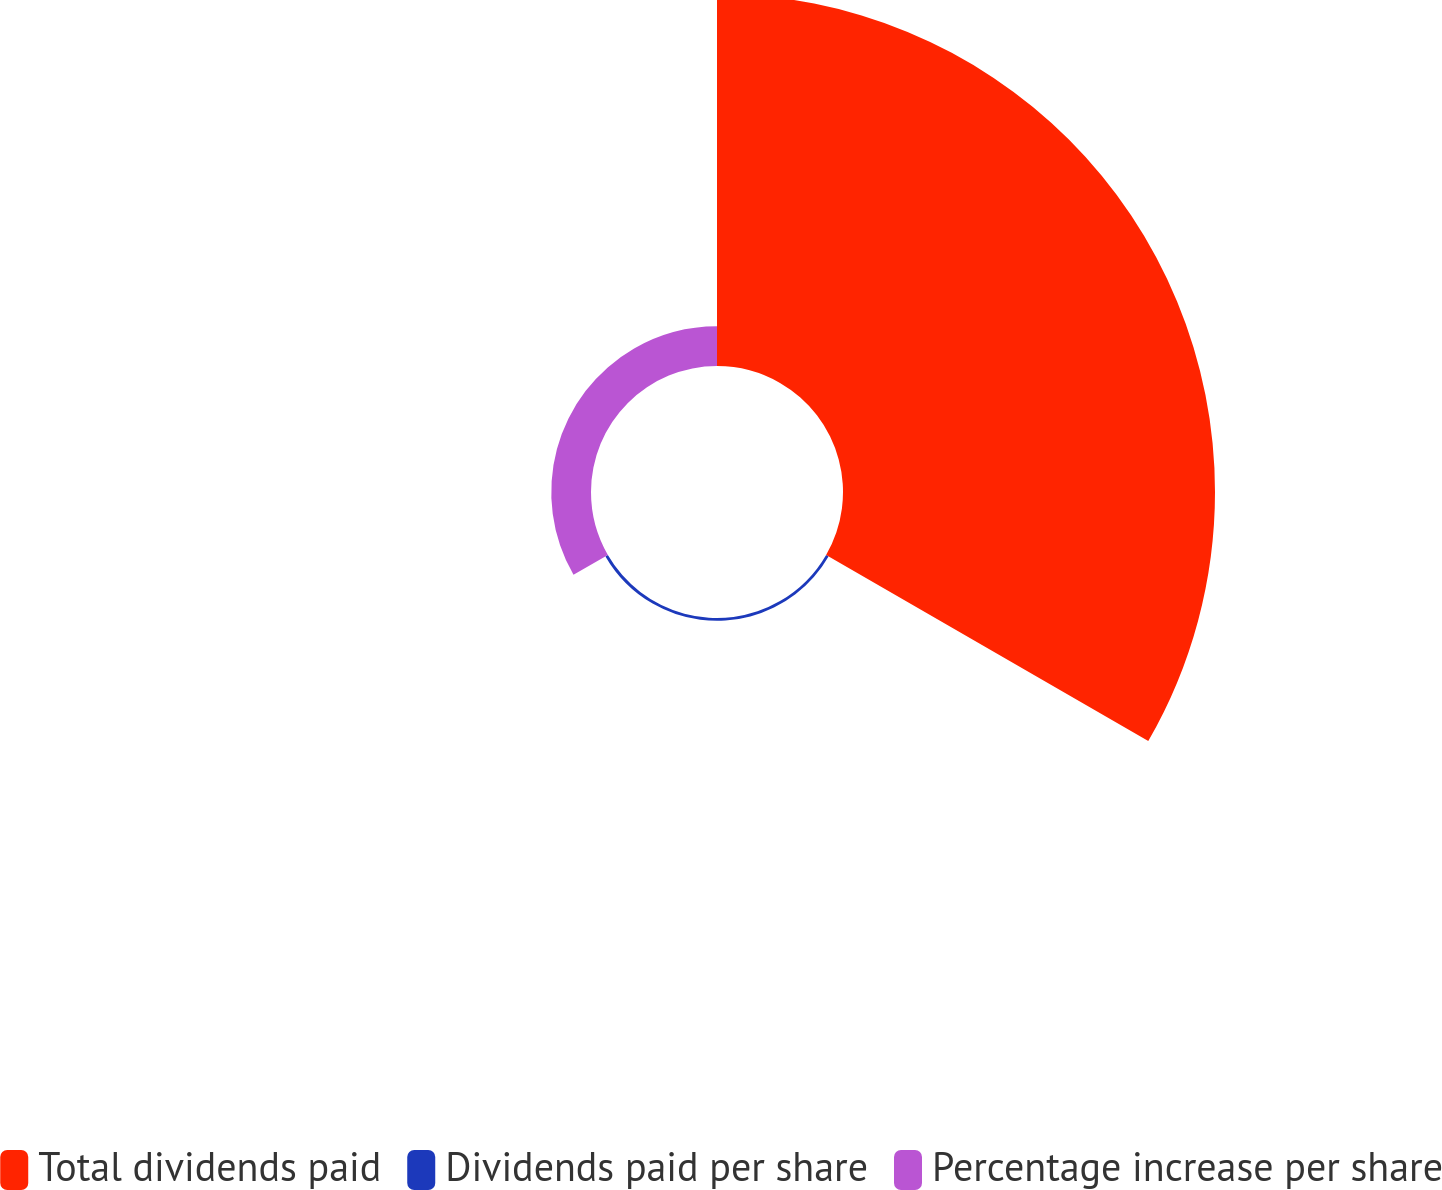Convert chart to OTSL. <chart><loc_0><loc_0><loc_500><loc_500><pie_chart><fcel>Total dividends paid<fcel>Dividends paid per share<fcel>Percentage increase per share<nl><fcel>89.74%<fcel>0.68%<fcel>9.58%<nl></chart> 